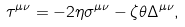Convert formula to latex. <formula><loc_0><loc_0><loc_500><loc_500>\tau ^ { \mu \nu } & = - 2 \eta \sigma ^ { \mu \nu } - \zeta \theta \Delta ^ { \mu \nu } ,</formula> 